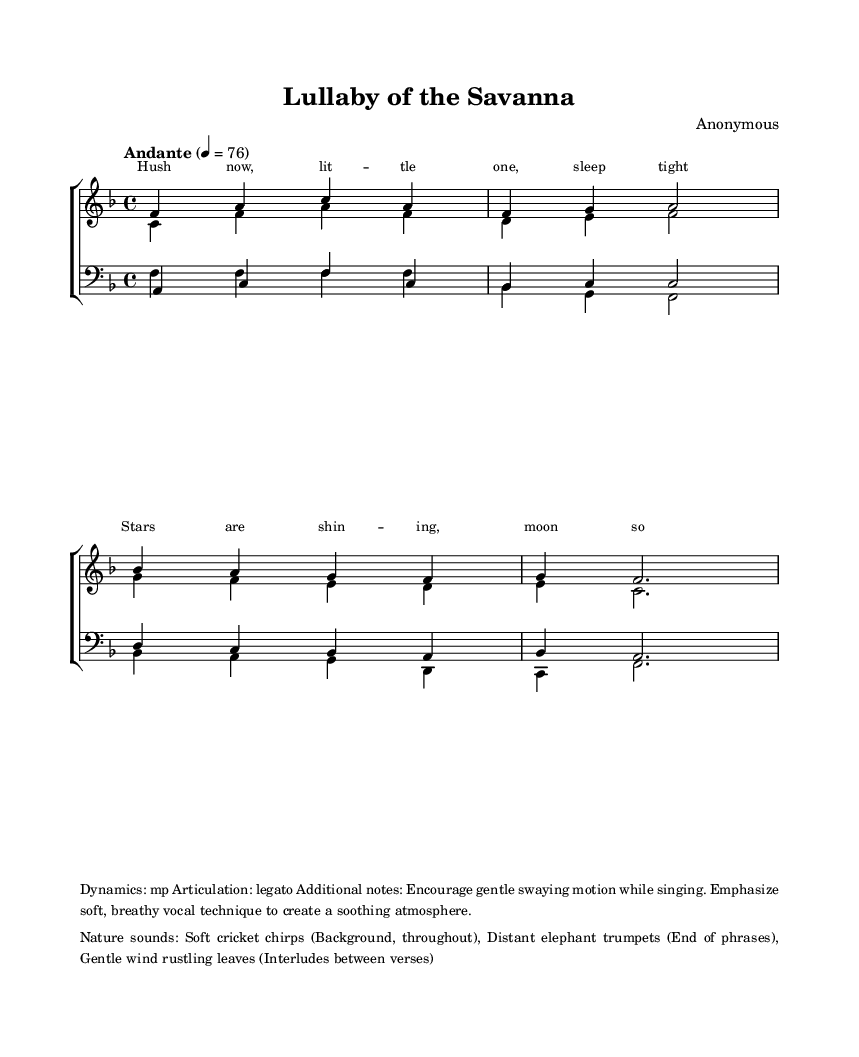What is the key signature of this music? The key signature is F major, which has one flat (B♭). This can be determined from the beginning of the staff where the F major key signature is indicated.
Answer: F major What is the time signature of this music? The time signature is 4/4, which means there are four beats in each measure and the quarter note gets one beat. This is visible at the beginning of the score next to the key signature.
Answer: 4/4 What is the tempo marking for this piece? The tempo marking is "Andante" with a metronome marking of 76. This can be found just above the staff at the start of the music, indicating the speed at which the piece should be played.
Answer: Andante, 76 How many vocal parts are there in this choir arrangement? There are four vocal parts: sopranos, altos, tenors, and basses. This is inferred from the separate staves labeled for women's and men's voices within the choir staff.
Answer: Four What dynamics are indicated for singing this piece? The dynamics indicated are "mp," which stands for "mezzo-piano" meaning moderately soft. This is noted in the markup section at the end of the score.
Answer: mp What nature sounds are suggested to accompany the music? The suggested nature sounds include soft cricket chirps, distant elephant trumpets, and gentle wind rustling leaves. These are outlined in the markup at the bottom of the sheet music, indicating a calming ambiance to complement the singing.
Answer: Cricket chirps, elephant trumpets, wind rustling leaves What is the title of this piece? The title of the piece is "Lullaby of the Savanna," which is clearly stated at the top of the sheet music under the header section.
Answer: Lullaby of the Savanna 